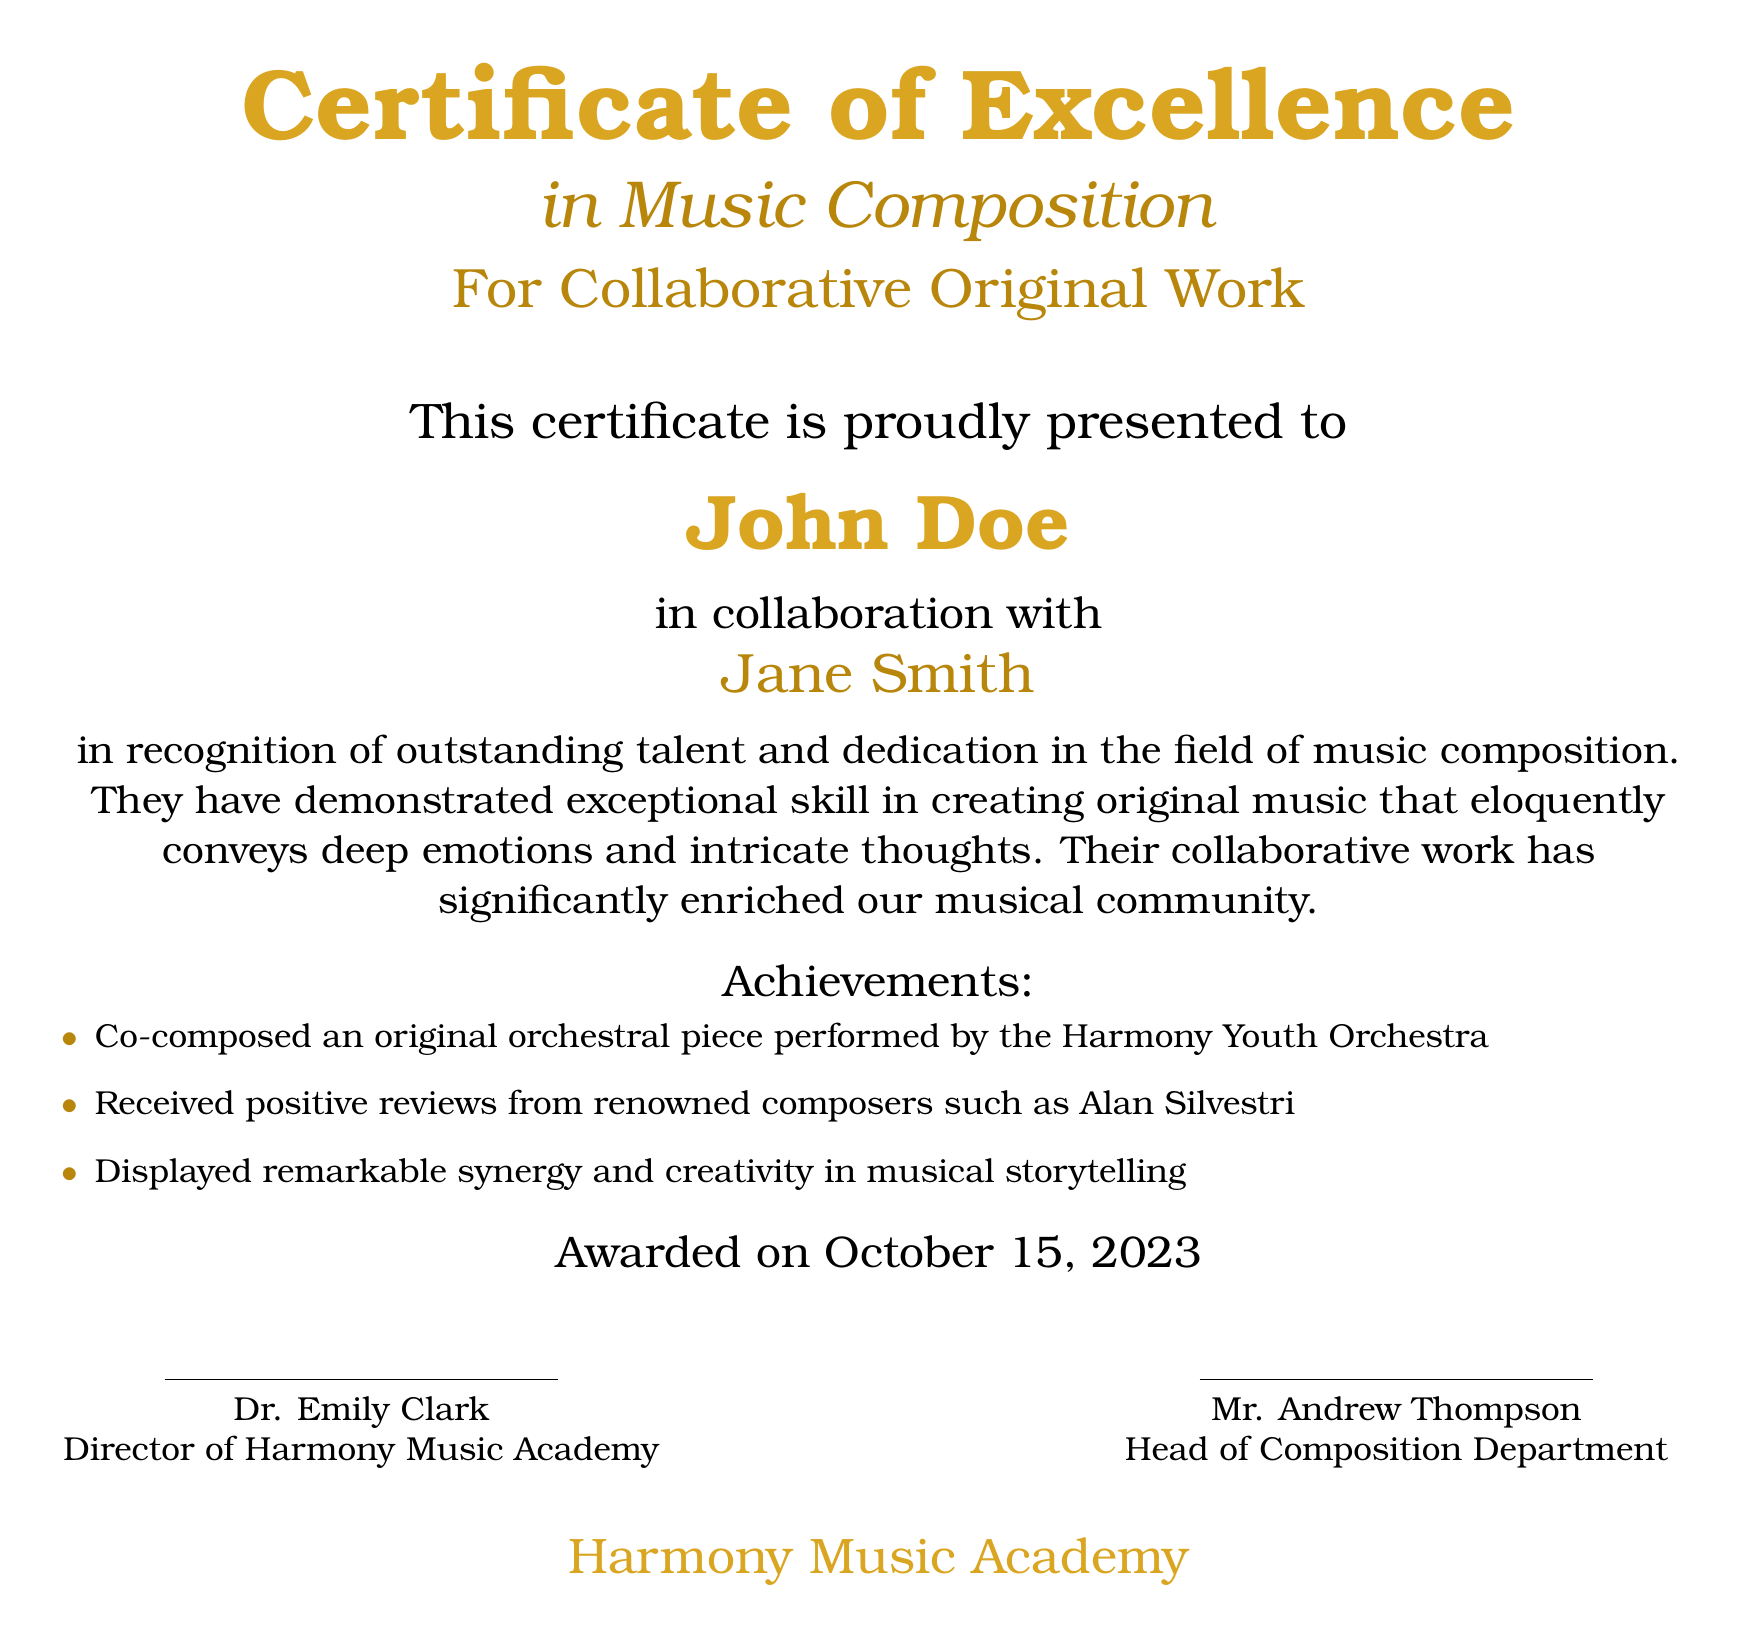What is the title of the certificate? The title is prominently displayed at the top of the document as "Certificate of Excellence".
Answer: Certificate of Excellence Who is the certificate presented to? The certificate is specifically presented to a person named in the document.
Answer: John Doe Who collaborated with John Doe on the music composition? The document indicates a person's name who worked together with John Doe.
Answer: Jane Smith What date was the certificate awarded? The certificate includes the date it was awarded, specified in the document.
Answer: October 15, 2023 What type of work is recognized in the certificate? The document states the nature of the work for which the certificate is awarded.
Answer: Collaborative Original Work Which orchestra performed the original piece co-composed by John Doe? The document mentions the name of the orchestra involved in the performance.
Answer: Harmony Youth Orchestra Who is the Director of Harmony Music Academy? The document provides the name of the individual holding this position.
Answer: Dr. Emily Clark What is one notable achievement of John Doe and Jane Smith mentioned in the document? The document lists various accomplishments and one can be reasonably extracted from the text.
Answer: Co-composed an original orchestral piece What color is used for the title on the certificate? The color used for the title is described in the document.
Answer: Gold What department does Mr. Andrew Thompson head? The document outlines the position of Mr. Andrew Thompson regarding departmental leadership.
Answer: Composition Department 